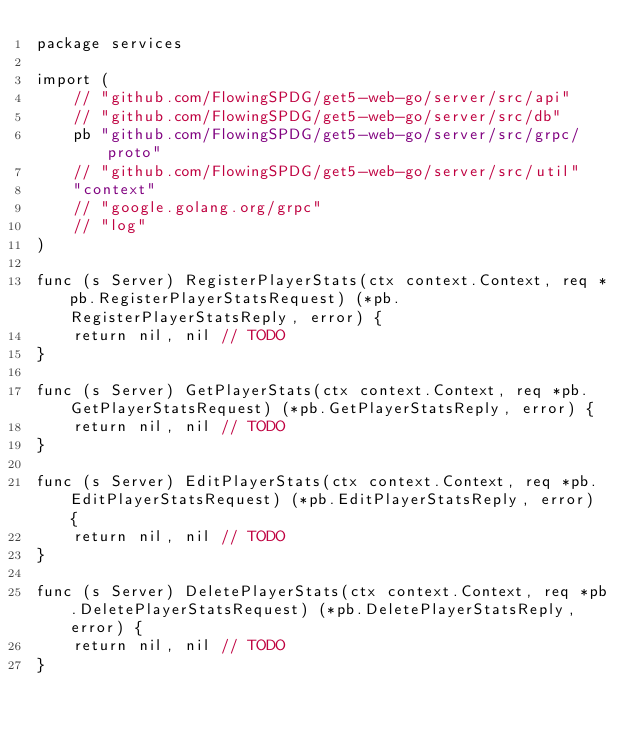Convert code to text. <code><loc_0><loc_0><loc_500><loc_500><_Go_>package services

import (
	// "github.com/FlowingSPDG/get5-web-go/server/src/api"
	// "github.com/FlowingSPDG/get5-web-go/server/src/db"
	pb "github.com/FlowingSPDG/get5-web-go/server/src/grpc/proto"
	// "github.com/FlowingSPDG/get5-web-go/server/src/util"
	"context"
	// "google.golang.org/grpc"
	// "log"
)

func (s Server) RegisterPlayerStats(ctx context.Context, req *pb.RegisterPlayerStatsRequest) (*pb.RegisterPlayerStatsReply, error) {
	return nil, nil // TODO
}

func (s Server) GetPlayerStats(ctx context.Context, req *pb.GetPlayerStatsRequest) (*pb.GetPlayerStatsReply, error) {
	return nil, nil // TODO
}

func (s Server) EditPlayerStats(ctx context.Context, req *pb.EditPlayerStatsRequest) (*pb.EditPlayerStatsReply, error) {
	return nil, nil // TODO
}

func (s Server) DeletePlayerStats(ctx context.Context, req *pb.DeletePlayerStatsRequest) (*pb.DeletePlayerStatsReply, error) {
	return nil, nil // TODO
}
</code> 